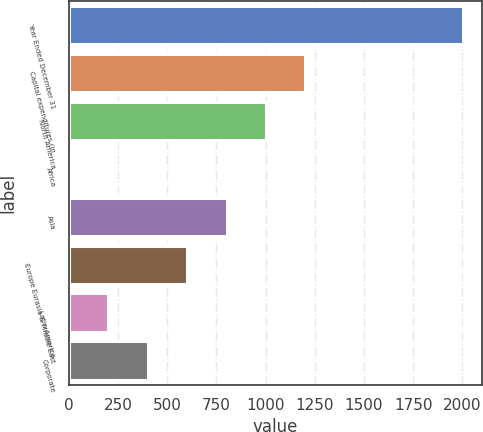Convert chart. <chart><loc_0><loc_0><loc_500><loc_500><bar_chart><fcel>Year Ended December 31<fcel>Capital expenditures (in<fcel>North America<fcel>Africa<fcel>Asia<fcel>Europe Eurasia & Middle East<fcel>Latin America<fcel>Corporate<nl><fcel>2002<fcel>1202<fcel>1002<fcel>2<fcel>802<fcel>602<fcel>202<fcel>402<nl></chart> 